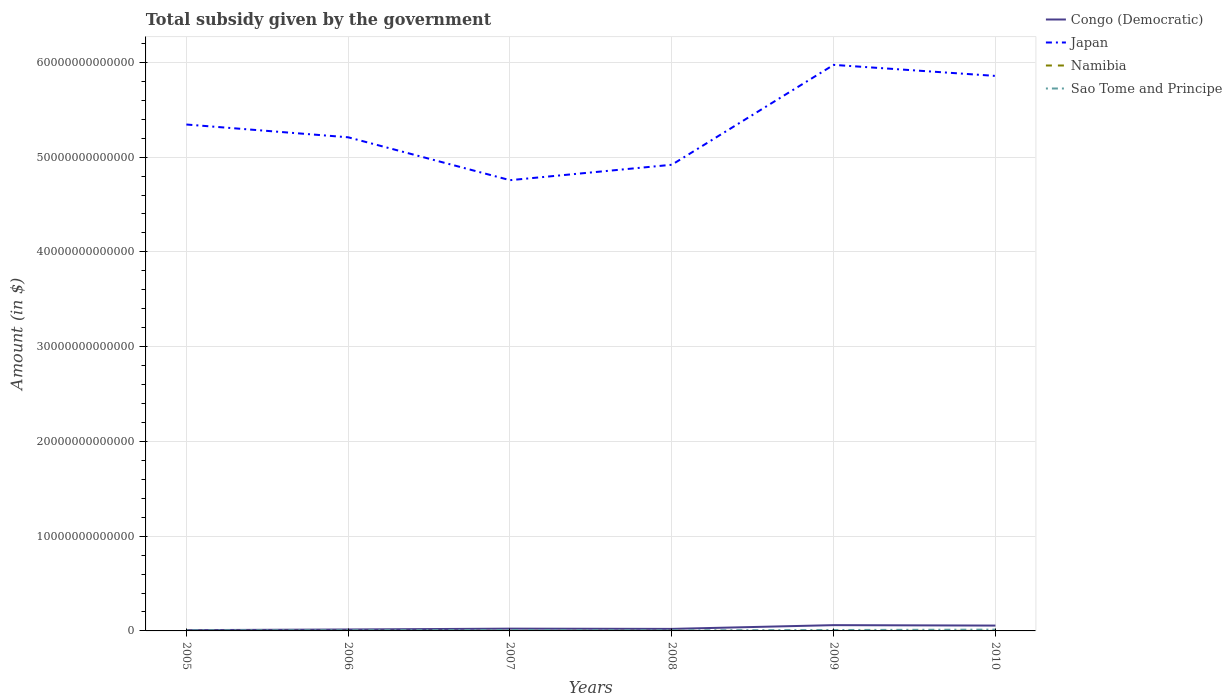Does the line corresponding to Japan intersect with the line corresponding to Sao Tome and Principe?
Keep it short and to the point. No. Is the number of lines equal to the number of legend labels?
Provide a short and direct response. Yes. Across all years, what is the maximum total revenue collected by the government in Congo (Democratic)?
Give a very brief answer. 8.19e+1. What is the total total revenue collected by the government in Sao Tome and Principe in the graph?
Offer a terse response. -3.54e+1. What is the difference between the highest and the second highest total revenue collected by the government in Congo (Democratic)?
Provide a succinct answer. 5.28e+11. Is the total revenue collected by the government in Congo (Democratic) strictly greater than the total revenue collected by the government in Japan over the years?
Provide a succinct answer. Yes. How many years are there in the graph?
Offer a very short reply. 6. What is the difference between two consecutive major ticks on the Y-axis?
Your response must be concise. 1.00e+13. Are the values on the major ticks of Y-axis written in scientific E-notation?
Your response must be concise. No. Does the graph contain any zero values?
Provide a succinct answer. No. How are the legend labels stacked?
Give a very brief answer. Vertical. What is the title of the graph?
Make the answer very short. Total subsidy given by the government. Does "Cambodia" appear as one of the legend labels in the graph?
Give a very brief answer. No. What is the label or title of the Y-axis?
Offer a very short reply. Amount (in $). What is the Amount (in $) in Congo (Democratic) in 2005?
Ensure brevity in your answer.  8.19e+1. What is the Amount (in $) in Japan in 2005?
Give a very brief answer. 5.34e+13. What is the Amount (in $) in Namibia in 2005?
Ensure brevity in your answer.  1.23e+09. What is the Amount (in $) of Sao Tome and Principe in 2005?
Provide a short and direct response. 5.85e+1. What is the Amount (in $) in Congo (Democratic) in 2006?
Your answer should be compact. 1.52e+11. What is the Amount (in $) of Japan in 2006?
Provide a short and direct response. 5.21e+13. What is the Amount (in $) in Namibia in 2006?
Your response must be concise. 1.30e+09. What is the Amount (in $) in Sao Tome and Principe in 2006?
Your response must be concise. 7.33e+1. What is the Amount (in $) in Congo (Democratic) in 2007?
Your response must be concise. 2.41e+11. What is the Amount (in $) in Japan in 2007?
Provide a succinct answer. 4.76e+13. What is the Amount (in $) in Namibia in 2007?
Provide a short and direct response. 1.99e+09. What is the Amount (in $) of Sao Tome and Principe in 2007?
Make the answer very short. 9.39e+1. What is the Amount (in $) of Congo (Democratic) in 2008?
Make the answer very short. 2.14e+11. What is the Amount (in $) of Japan in 2008?
Keep it short and to the point. 4.92e+13. What is the Amount (in $) in Namibia in 2008?
Your answer should be compact. 5.21e+09. What is the Amount (in $) in Sao Tome and Principe in 2008?
Your answer should be compact. 6.06e+1. What is the Amount (in $) of Congo (Democratic) in 2009?
Offer a terse response. 6.10e+11. What is the Amount (in $) in Japan in 2009?
Your answer should be compact. 5.97e+13. What is the Amount (in $) in Namibia in 2009?
Your answer should be compact. 5.81e+09. What is the Amount (in $) of Sao Tome and Principe in 2009?
Ensure brevity in your answer.  9.66e+1. What is the Amount (in $) in Congo (Democratic) in 2010?
Keep it short and to the point. 5.64e+11. What is the Amount (in $) in Japan in 2010?
Offer a very short reply. 5.86e+13. What is the Amount (in $) in Namibia in 2010?
Your answer should be compact. 7.49e+09. What is the Amount (in $) in Sao Tome and Principe in 2010?
Keep it short and to the point. 1.37e+11. Across all years, what is the maximum Amount (in $) in Congo (Democratic)?
Make the answer very short. 6.10e+11. Across all years, what is the maximum Amount (in $) in Japan?
Provide a short and direct response. 5.97e+13. Across all years, what is the maximum Amount (in $) of Namibia?
Make the answer very short. 7.49e+09. Across all years, what is the maximum Amount (in $) of Sao Tome and Principe?
Provide a short and direct response. 1.37e+11. Across all years, what is the minimum Amount (in $) of Congo (Democratic)?
Ensure brevity in your answer.  8.19e+1. Across all years, what is the minimum Amount (in $) in Japan?
Your answer should be very brief. 4.76e+13. Across all years, what is the minimum Amount (in $) in Namibia?
Give a very brief answer. 1.23e+09. Across all years, what is the minimum Amount (in $) in Sao Tome and Principe?
Make the answer very short. 5.85e+1. What is the total Amount (in $) in Congo (Democratic) in the graph?
Provide a short and direct response. 1.86e+12. What is the total Amount (in $) in Japan in the graph?
Make the answer very short. 3.21e+14. What is the total Amount (in $) in Namibia in the graph?
Ensure brevity in your answer.  2.30e+1. What is the total Amount (in $) in Sao Tome and Principe in the graph?
Keep it short and to the point. 5.20e+11. What is the difference between the Amount (in $) of Congo (Democratic) in 2005 and that in 2006?
Your answer should be compact. -6.97e+1. What is the difference between the Amount (in $) of Japan in 2005 and that in 2006?
Your response must be concise. 1.35e+12. What is the difference between the Amount (in $) in Namibia in 2005 and that in 2006?
Your answer should be very brief. -7.44e+07. What is the difference between the Amount (in $) of Sao Tome and Principe in 2005 and that in 2006?
Keep it short and to the point. -1.48e+1. What is the difference between the Amount (in $) of Congo (Democratic) in 2005 and that in 2007?
Provide a short and direct response. -1.59e+11. What is the difference between the Amount (in $) in Japan in 2005 and that in 2007?
Provide a succinct answer. 5.87e+12. What is the difference between the Amount (in $) of Namibia in 2005 and that in 2007?
Your answer should be compact. -7.63e+08. What is the difference between the Amount (in $) in Sao Tome and Principe in 2005 and that in 2007?
Offer a very short reply. -3.54e+1. What is the difference between the Amount (in $) in Congo (Democratic) in 2005 and that in 2008?
Make the answer very short. -1.32e+11. What is the difference between the Amount (in $) in Japan in 2005 and that in 2008?
Provide a short and direct response. 4.25e+12. What is the difference between the Amount (in $) of Namibia in 2005 and that in 2008?
Your answer should be compact. -3.98e+09. What is the difference between the Amount (in $) in Sao Tome and Principe in 2005 and that in 2008?
Your response must be concise. -2.04e+09. What is the difference between the Amount (in $) in Congo (Democratic) in 2005 and that in 2009?
Offer a terse response. -5.28e+11. What is the difference between the Amount (in $) of Japan in 2005 and that in 2009?
Make the answer very short. -6.29e+12. What is the difference between the Amount (in $) in Namibia in 2005 and that in 2009?
Your answer should be very brief. -4.58e+09. What is the difference between the Amount (in $) in Sao Tome and Principe in 2005 and that in 2009?
Your answer should be very brief. -3.81e+1. What is the difference between the Amount (in $) in Congo (Democratic) in 2005 and that in 2010?
Your answer should be very brief. -4.82e+11. What is the difference between the Amount (in $) of Japan in 2005 and that in 2010?
Offer a very short reply. -5.13e+12. What is the difference between the Amount (in $) of Namibia in 2005 and that in 2010?
Offer a very short reply. -6.26e+09. What is the difference between the Amount (in $) in Sao Tome and Principe in 2005 and that in 2010?
Give a very brief answer. -7.83e+1. What is the difference between the Amount (in $) in Congo (Democratic) in 2006 and that in 2007?
Provide a short and direct response. -8.91e+1. What is the difference between the Amount (in $) of Japan in 2006 and that in 2007?
Make the answer very short. 4.53e+12. What is the difference between the Amount (in $) of Namibia in 2006 and that in 2007?
Your response must be concise. -6.88e+08. What is the difference between the Amount (in $) in Sao Tome and Principe in 2006 and that in 2007?
Keep it short and to the point. -2.06e+1. What is the difference between the Amount (in $) in Congo (Democratic) in 2006 and that in 2008?
Your answer should be very brief. -6.25e+1. What is the difference between the Amount (in $) of Japan in 2006 and that in 2008?
Your answer should be very brief. 2.90e+12. What is the difference between the Amount (in $) of Namibia in 2006 and that in 2008?
Your response must be concise. -3.91e+09. What is the difference between the Amount (in $) in Sao Tome and Principe in 2006 and that in 2008?
Keep it short and to the point. 1.28e+1. What is the difference between the Amount (in $) of Congo (Democratic) in 2006 and that in 2009?
Provide a short and direct response. -4.58e+11. What is the difference between the Amount (in $) of Japan in 2006 and that in 2009?
Offer a terse response. -7.64e+12. What is the difference between the Amount (in $) of Namibia in 2006 and that in 2009?
Offer a terse response. -4.51e+09. What is the difference between the Amount (in $) of Sao Tome and Principe in 2006 and that in 2009?
Offer a terse response. -2.33e+1. What is the difference between the Amount (in $) of Congo (Democratic) in 2006 and that in 2010?
Your answer should be very brief. -4.12e+11. What is the difference between the Amount (in $) in Japan in 2006 and that in 2010?
Offer a terse response. -6.48e+12. What is the difference between the Amount (in $) in Namibia in 2006 and that in 2010?
Provide a succinct answer. -6.18e+09. What is the difference between the Amount (in $) of Sao Tome and Principe in 2006 and that in 2010?
Your answer should be very brief. -6.35e+1. What is the difference between the Amount (in $) in Congo (Democratic) in 2007 and that in 2008?
Your answer should be very brief. 2.66e+1. What is the difference between the Amount (in $) of Japan in 2007 and that in 2008?
Make the answer very short. -1.63e+12. What is the difference between the Amount (in $) of Namibia in 2007 and that in 2008?
Offer a terse response. -3.22e+09. What is the difference between the Amount (in $) of Sao Tome and Principe in 2007 and that in 2008?
Your answer should be very brief. 3.34e+1. What is the difference between the Amount (in $) in Congo (Democratic) in 2007 and that in 2009?
Your response must be concise. -3.69e+11. What is the difference between the Amount (in $) in Japan in 2007 and that in 2009?
Make the answer very short. -1.22e+13. What is the difference between the Amount (in $) of Namibia in 2007 and that in 2009?
Ensure brevity in your answer.  -3.82e+09. What is the difference between the Amount (in $) in Sao Tome and Principe in 2007 and that in 2009?
Keep it short and to the point. -2.74e+09. What is the difference between the Amount (in $) of Congo (Democratic) in 2007 and that in 2010?
Provide a short and direct response. -3.23e+11. What is the difference between the Amount (in $) in Japan in 2007 and that in 2010?
Provide a succinct answer. -1.10e+13. What is the difference between the Amount (in $) in Namibia in 2007 and that in 2010?
Make the answer very short. -5.49e+09. What is the difference between the Amount (in $) of Sao Tome and Principe in 2007 and that in 2010?
Offer a terse response. -4.29e+1. What is the difference between the Amount (in $) in Congo (Democratic) in 2008 and that in 2009?
Make the answer very short. -3.96e+11. What is the difference between the Amount (in $) of Japan in 2008 and that in 2009?
Provide a short and direct response. -1.05e+13. What is the difference between the Amount (in $) of Namibia in 2008 and that in 2009?
Your answer should be very brief. -6.00e+08. What is the difference between the Amount (in $) of Sao Tome and Principe in 2008 and that in 2009?
Your answer should be compact. -3.61e+1. What is the difference between the Amount (in $) of Congo (Democratic) in 2008 and that in 2010?
Make the answer very short. -3.50e+11. What is the difference between the Amount (in $) in Japan in 2008 and that in 2010?
Provide a succinct answer. -9.38e+12. What is the difference between the Amount (in $) of Namibia in 2008 and that in 2010?
Keep it short and to the point. -2.28e+09. What is the difference between the Amount (in $) of Sao Tome and Principe in 2008 and that in 2010?
Your answer should be compact. -7.63e+1. What is the difference between the Amount (in $) in Congo (Democratic) in 2009 and that in 2010?
Make the answer very short. 4.60e+1. What is the difference between the Amount (in $) in Japan in 2009 and that in 2010?
Provide a short and direct response. 1.16e+12. What is the difference between the Amount (in $) of Namibia in 2009 and that in 2010?
Provide a succinct answer. -1.68e+09. What is the difference between the Amount (in $) in Sao Tome and Principe in 2009 and that in 2010?
Your answer should be compact. -4.02e+1. What is the difference between the Amount (in $) in Congo (Democratic) in 2005 and the Amount (in $) in Japan in 2006?
Your response must be concise. -5.20e+13. What is the difference between the Amount (in $) of Congo (Democratic) in 2005 and the Amount (in $) of Namibia in 2006?
Your response must be concise. 8.06e+1. What is the difference between the Amount (in $) of Congo (Democratic) in 2005 and the Amount (in $) of Sao Tome and Principe in 2006?
Your answer should be compact. 8.57e+09. What is the difference between the Amount (in $) in Japan in 2005 and the Amount (in $) in Namibia in 2006?
Your answer should be very brief. 5.34e+13. What is the difference between the Amount (in $) of Japan in 2005 and the Amount (in $) of Sao Tome and Principe in 2006?
Keep it short and to the point. 5.34e+13. What is the difference between the Amount (in $) of Namibia in 2005 and the Amount (in $) of Sao Tome and Principe in 2006?
Make the answer very short. -7.21e+1. What is the difference between the Amount (in $) in Congo (Democratic) in 2005 and the Amount (in $) in Japan in 2007?
Offer a very short reply. -4.75e+13. What is the difference between the Amount (in $) in Congo (Democratic) in 2005 and the Amount (in $) in Namibia in 2007?
Ensure brevity in your answer.  7.99e+1. What is the difference between the Amount (in $) in Congo (Democratic) in 2005 and the Amount (in $) in Sao Tome and Principe in 2007?
Your response must be concise. -1.20e+1. What is the difference between the Amount (in $) in Japan in 2005 and the Amount (in $) in Namibia in 2007?
Give a very brief answer. 5.34e+13. What is the difference between the Amount (in $) in Japan in 2005 and the Amount (in $) in Sao Tome and Principe in 2007?
Your answer should be very brief. 5.33e+13. What is the difference between the Amount (in $) in Namibia in 2005 and the Amount (in $) in Sao Tome and Principe in 2007?
Provide a succinct answer. -9.27e+1. What is the difference between the Amount (in $) of Congo (Democratic) in 2005 and the Amount (in $) of Japan in 2008?
Your answer should be compact. -4.91e+13. What is the difference between the Amount (in $) of Congo (Democratic) in 2005 and the Amount (in $) of Namibia in 2008?
Your answer should be very brief. 7.67e+1. What is the difference between the Amount (in $) of Congo (Democratic) in 2005 and the Amount (in $) of Sao Tome and Principe in 2008?
Keep it short and to the point. 2.13e+1. What is the difference between the Amount (in $) of Japan in 2005 and the Amount (in $) of Namibia in 2008?
Your answer should be very brief. 5.34e+13. What is the difference between the Amount (in $) in Japan in 2005 and the Amount (in $) in Sao Tome and Principe in 2008?
Provide a short and direct response. 5.34e+13. What is the difference between the Amount (in $) in Namibia in 2005 and the Amount (in $) in Sao Tome and Principe in 2008?
Give a very brief answer. -5.93e+1. What is the difference between the Amount (in $) in Congo (Democratic) in 2005 and the Amount (in $) in Japan in 2009?
Offer a terse response. -5.97e+13. What is the difference between the Amount (in $) in Congo (Democratic) in 2005 and the Amount (in $) in Namibia in 2009?
Your response must be concise. 7.61e+1. What is the difference between the Amount (in $) in Congo (Democratic) in 2005 and the Amount (in $) in Sao Tome and Principe in 2009?
Offer a very short reply. -1.48e+1. What is the difference between the Amount (in $) of Japan in 2005 and the Amount (in $) of Namibia in 2009?
Keep it short and to the point. 5.34e+13. What is the difference between the Amount (in $) in Japan in 2005 and the Amount (in $) in Sao Tome and Principe in 2009?
Give a very brief answer. 5.33e+13. What is the difference between the Amount (in $) of Namibia in 2005 and the Amount (in $) of Sao Tome and Principe in 2009?
Provide a short and direct response. -9.54e+1. What is the difference between the Amount (in $) in Congo (Democratic) in 2005 and the Amount (in $) in Japan in 2010?
Your answer should be very brief. -5.85e+13. What is the difference between the Amount (in $) in Congo (Democratic) in 2005 and the Amount (in $) in Namibia in 2010?
Your response must be concise. 7.44e+1. What is the difference between the Amount (in $) in Congo (Democratic) in 2005 and the Amount (in $) in Sao Tome and Principe in 2010?
Give a very brief answer. -5.50e+1. What is the difference between the Amount (in $) of Japan in 2005 and the Amount (in $) of Namibia in 2010?
Offer a terse response. 5.34e+13. What is the difference between the Amount (in $) of Japan in 2005 and the Amount (in $) of Sao Tome and Principe in 2010?
Your response must be concise. 5.33e+13. What is the difference between the Amount (in $) in Namibia in 2005 and the Amount (in $) in Sao Tome and Principe in 2010?
Provide a short and direct response. -1.36e+11. What is the difference between the Amount (in $) in Congo (Democratic) in 2006 and the Amount (in $) in Japan in 2007?
Offer a very short reply. -4.74e+13. What is the difference between the Amount (in $) of Congo (Democratic) in 2006 and the Amount (in $) of Namibia in 2007?
Give a very brief answer. 1.50e+11. What is the difference between the Amount (in $) in Congo (Democratic) in 2006 and the Amount (in $) in Sao Tome and Principe in 2007?
Offer a terse response. 5.77e+1. What is the difference between the Amount (in $) of Japan in 2006 and the Amount (in $) of Namibia in 2007?
Make the answer very short. 5.21e+13. What is the difference between the Amount (in $) of Japan in 2006 and the Amount (in $) of Sao Tome and Principe in 2007?
Your answer should be very brief. 5.20e+13. What is the difference between the Amount (in $) in Namibia in 2006 and the Amount (in $) in Sao Tome and Principe in 2007?
Provide a short and direct response. -9.26e+1. What is the difference between the Amount (in $) of Congo (Democratic) in 2006 and the Amount (in $) of Japan in 2008?
Provide a succinct answer. -4.90e+13. What is the difference between the Amount (in $) in Congo (Democratic) in 2006 and the Amount (in $) in Namibia in 2008?
Your answer should be very brief. 1.46e+11. What is the difference between the Amount (in $) of Congo (Democratic) in 2006 and the Amount (in $) of Sao Tome and Principe in 2008?
Offer a terse response. 9.10e+1. What is the difference between the Amount (in $) in Japan in 2006 and the Amount (in $) in Namibia in 2008?
Your answer should be compact. 5.21e+13. What is the difference between the Amount (in $) of Japan in 2006 and the Amount (in $) of Sao Tome and Principe in 2008?
Ensure brevity in your answer.  5.20e+13. What is the difference between the Amount (in $) of Namibia in 2006 and the Amount (in $) of Sao Tome and Principe in 2008?
Ensure brevity in your answer.  -5.92e+1. What is the difference between the Amount (in $) of Congo (Democratic) in 2006 and the Amount (in $) of Japan in 2009?
Your answer should be very brief. -5.96e+13. What is the difference between the Amount (in $) of Congo (Democratic) in 2006 and the Amount (in $) of Namibia in 2009?
Your answer should be very brief. 1.46e+11. What is the difference between the Amount (in $) of Congo (Democratic) in 2006 and the Amount (in $) of Sao Tome and Principe in 2009?
Ensure brevity in your answer.  5.49e+1. What is the difference between the Amount (in $) of Japan in 2006 and the Amount (in $) of Namibia in 2009?
Give a very brief answer. 5.21e+13. What is the difference between the Amount (in $) in Japan in 2006 and the Amount (in $) in Sao Tome and Principe in 2009?
Give a very brief answer. 5.20e+13. What is the difference between the Amount (in $) of Namibia in 2006 and the Amount (in $) of Sao Tome and Principe in 2009?
Make the answer very short. -9.53e+1. What is the difference between the Amount (in $) of Congo (Democratic) in 2006 and the Amount (in $) of Japan in 2010?
Give a very brief answer. -5.84e+13. What is the difference between the Amount (in $) of Congo (Democratic) in 2006 and the Amount (in $) of Namibia in 2010?
Keep it short and to the point. 1.44e+11. What is the difference between the Amount (in $) in Congo (Democratic) in 2006 and the Amount (in $) in Sao Tome and Principe in 2010?
Your answer should be compact. 1.47e+1. What is the difference between the Amount (in $) in Japan in 2006 and the Amount (in $) in Namibia in 2010?
Provide a succinct answer. 5.21e+13. What is the difference between the Amount (in $) in Japan in 2006 and the Amount (in $) in Sao Tome and Principe in 2010?
Your answer should be very brief. 5.20e+13. What is the difference between the Amount (in $) in Namibia in 2006 and the Amount (in $) in Sao Tome and Principe in 2010?
Your answer should be very brief. -1.36e+11. What is the difference between the Amount (in $) in Congo (Democratic) in 2007 and the Amount (in $) in Japan in 2008?
Give a very brief answer. -4.90e+13. What is the difference between the Amount (in $) of Congo (Democratic) in 2007 and the Amount (in $) of Namibia in 2008?
Provide a succinct answer. 2.36e+11. What is the difference between the Amount (in $) of Congo (Democratic) in 2007 and the Amount (in $) of Sao Tome and Principe in 2008?
Your answer should be compact. 1.80e+11. What is the difference between the Amount (in $) of Japan in 2007 and the Amount (in $) of Namibia in 2008?
Provide a short and direct response. 4.76e+13. What is the difference between the Amount (in $) of Japan in 2007 and the Amount (in $) of Sao Tome and Principe in 2008?
Offer a terse response. 4.75e+13. What is the difference between the Amount (in $) in Namibia in 2007 and the Amount (in $) in Sao Tome and Principe in 2008?
Your answer should be very brief. -5.86e+1. What is the difference between the Amount (in $) in Congo (Democratic) in 2007 and the Amount (in $) in Japan in 2009?
Your response must be concise. -5.95e+13. What is the difference between the Amount (in $) of Congo (Democratic) in 2007 and the Amount (in $) of Namibia in 2009?
Your response must be concise. 2.35e+11. What is the difference between the Amount (in $) of Congo (Democratic) in 2007 and the Amount (in $) of Sao Tome and Principe in 2009?
Offer a terse response. 1.44e+11. What is the difference between the Amount (in $) in Japan in 2007 and the Amount (in $) in Namibia in 2009?
Your response must be concise. 4.76e+13. What is the difference between the Amount (in $) of Japan in 2007 and the Amount (in $) of Sao Tome and Principe in 2009?
Provide a short and direct response. 4.75e+13. What is the difference between the Amount (in $) in Namibia in 2007 and the Amount (in $) in Sao Tome and Principe in 2009?
Ensure brevity in your answer.  -9.47e+1. What is the difference between the Amount (in $) in Congo (Democratic) in 2007 and the Amount (in $) in Japan in 2010?
Your answer should be compact. -5.83e+13. What is the difference between the Amount (in $) in Congo (Democratic) in 2007 and the Amount (in $) in Namibia in 2010?
Your answer should be very brief. 2.33e+11. What is the difference between the Amount (in $) of Congo (Democratic) in 2007 and the Amount (in $) of Sao Tome and Principe in 2010?
Give a very brief answer. 1.04e+11. What is the difference between the Amount (in $) of Japan in 2007 and the Amount (in $) of Namibia in 2010?
Provide a succinct answer. 4.76e+13. What is the difference between the Amount (in $) of Japan in 2007 and the Amount (in $) of Sao Tome and Principe in 2010?
Offer a terse response. 4.74e+13. What is the difference between the Amount (in $) in Namibia in 2007 and the Amount (in $) in Sao Tome and Principe in 2010?
Your response must be concise. -1.35e+11. What is the difference between the Amount (in $) of Congo (Democratic) in 2008 and the Amount (in $) of Japan in 2009?
Keep it short and to the point. -5.95e+13. What is the difference between the Amount (in $) of Congo (Democratic) in 2008 and the Amount (in $) of Namibia in 2009?
Offer a terse response. 2.08e+11. What is the difference between the Amount (in $) in Congo (Democratic) in 2008 and the Amount (in $) in Sao Tome and Principe in 2009?
Your response must be concise. 1.17e+11. What is the difference between the Amount (in $) of Japan in 2008 and the Amount (in $) of Namibia in 2009?
Provide a succinct answer. 4.92e+13. What is the difference between the Amount (in $) in Japan in 2008 and the Amount (in $) in Sao Tome and Principe in 2009?
Your answer should be very brief. 4.91e+13. What is the difference between the Amount (in $) in Namibia in 2008 and the Amount (in $) in Sao Tome and Principe in 2009?
Keep it short and to the point. -9.14e+1. What is the difference between the Amount (in $) of Congo (Democratic) in 2008 and the Amount (in $) of Japan in 2010?
Make the answer very short. -5.84e+13. What is the difference between the Amount (in $) of Congo (Democratic) in 2008 and the Amount (in $) of Namibia in 2010?
Give a very brief answer. 2.07e+11. What is the difference between the Amount (in $) in Congo (Democratic) in 2008 and the Amount (in $) in Sao Tome and Principe in 2010?
Provide a short and direct response. 7.73e+1. What is the difference between the Amount (in $) in Japan in 2008 and the Amount (in $) in Namibia in 2010?
Your answer should be compact. 4.92e+13. What is the difference between the Amount (in $) of Japan in 2008 and the Amount (in $) of Sao Tome and Principe in 2010?
Provide a short and direct response. 4.91e+13. What is the difference between the Amount (in $) in Namibia in 2008 and the Amount (in $) in Sao Tome and Principe in 2010?
Provide a succinct answer. -1.32e+11. What is the difference between the Amount (in $) in Congo (Democratic) in 2009 and the Amount (in $) in Japan in 2010?
Offer a very short reply. -5.80e+13. What is the difference between the Amount (in $) in Congo (Democratic) in 2009 and the Amount (in $) in Namibia in 2010?
Your answer should be very brief. 6.02e+11. What is the difference between the Amount (in $) of Congo (Democratic) in 2009 and the Amount (in $) of Sao Tome and Principe in 2010?
Your answer should be compact. 4.73e+11. What is the difference between the Amount (in $) in Japan in 2009 and the Amount (in $) in Namibia in 2010?
Make the answer very short. 5.97e+13. What is the difference between the Amount (in $) in Japan in 2009 and the Amount (in $) in Sao Tome and Principe in 2010?
Your response must be concise. 5.96e+13. What is the difference between the Amount (in $) in Namibia in 2009 and the Amount (in $) in Sao Tome and Principe in 2010?
Your answer should be compact. -1.31e+11. What is the average Amount (in $) in Congo (Democratic) per year?
Provide a short and direct response. 3.10e+11. What is the average Amount (in $) of Japan per year?
Give a very brief answer. 5.34e+13. What is the average Amount (in $) of Namibia per year?
Make the answer very short. 3.84e+09. What is the average Amount (in $) in Sao Tome and Principe per year?
Make the answer very short. 8.66e+1. In the year 2005, what is the difference between the Amount (in $) in Congo (Democratic) and Amount (in $) in Japan?
Keep it short and to the point. -5.34e+13. In the year 2005, what is the difference between the Amount (in $) of Congo (Democratic) and Amount (in $) of Namibia?
Your answer should be very brief. 8.07e+1. In the year 2005, what is the difference between the Amount (in $) in Congo (Democratic) and Amount (in $) in Sao Tome and Principe?
Provide a succinct answer. 2.34e+1. In the year 2005, what is the difference between the Amount (in $) of Japan and Amount (in $) of Namibia?
Give a very brief answer. 5.34e+13. In the year 2005, what is the difference between the Amount (in $) of Japan and Amount (in $) of Sao Tome and Principe?
Provide a short and direct response. 5.34e+13. In the year 2005, what is the difference between the Amount (in $) of Namibia and Amount (in $) of Sao Tome and Principe?
Your response must be concise. -5.73e+1. In the year 2006, what is the difference between the Amount (in $) of Congo (Democratic) and Amount (in $) of Japan?
Make the answer very short. -5.19e+13. In the year 2006, what is the difference between the Amount (in $) of Congo (Democratic) and Amount (in $) of Namibia?
Ensure brevity in your answer.  1.50e+11. In the year 2006, what is the difference between the Amount (in $) of Congo (Democratic) and Amount (in $) of Sao Tome and Principe?
Provide a short and direct response. 7.83e+1. In the year 2006, what is the difference between the Amount (in $) in Japan and Amount (in $) in Namibia?
Give a very brief answer. 5.21e+13. In the year 2006, what is the difference between the Amount (in $) in Japan and Amount (in $) in Sao Tome and Principe?
Ensure brevity in your answer.  5.20e+13. In the year 2006, what is the difference between the Amount (in $) of Namibia and Amount (in $) of Sao Tome and Principe?
Your answer should be compact. -7.20e+1. In the year 2007, what is the difference between the Amount (in $) in Congo (Democratic) and Amount (in $) in Japan?
Give a very brief answer. -4.73e+13. In the year 2007, what is the difference between the Amount (in $) of Congo (Democratic) and Amount (in $) of Namibia?
Provide a succinct answer. 2.39e+11. In the year 2007, what is the difference between the Amount (in $) of Congo (Democratic) and Amount (in $) of Sao Tome and Principe?
Your answer should be compact. 1.47e+11. In the year 2007, what is the difference between the Amount (in $) in Japan and Amount (in $) in Namibia?
Offer a very short reply. 4.76e+13. In the year 2007, what is the difference between the Amount (in $) of Japan and Amount (in $) of Sao Tome and Principe?
Provide a succinct answer. 4.75e+13. In the year 2007, what is the difference between the Amount (in $) in Namibia and Amount (in $) in Sao Tome and Principe?
Your answer should be compact. -9.19e+1. In the year 2008, what is the difference between the Amount (in $) in Congo (Democratic) and Amount (in $) in Japan?
Offer a very short reply. -4.90e+13. In the year 2008, what is the difference between the Amount (in $) of Congo (Democratic) and Amount (in $) of Namibia?
Provide a succinct answer. 2.09e+11. In the year 2008, what is the difference between the Amount (in $) of Congo (Democratic) and Amount (in $) of Sao Tome and Principe?
Give a very brief answer. 1.54e+11. In the year 2008, what is the difference between the Amount (in $) in Japan and Amount (in $) in Namibia?
Offer a very short reply. 4.92e+13. In the year 2008, what is the difference between the Amount (in $) of Japan and Amount (in $) of Sao Tome and Principe?
Provide a succinct answer. 4.91e+13. In the year 2008, what is the difference between the Amount (in $) in Namibia and Amount (in $) in Sao Tome and Principe?
Offer a terse response. -5.53e+1. In the year 2009, what is the difference between the Amount (in $) of Congo (Democratic) and Amount (in $) of Japan?
Provide a succinct answer. -5.91e+13. In the year 2009, what is the difference between the Amount (in $) of Congo (Democratic) and Amount (in $) of Namibia?
Make the answer very short. 6.04e+11. In the year 2009, what is the difference between the Amount (in $) of Congo (Democratic) and Amount (in $) of Sao Tome and Principe?
Your answer should be compact. 5.13e+11. In the year 2009, what is the difference between the Amount (in $) of Japan and Amount (in $) of Namibia?
Keep it short and to the point. 5.97e+13. In the year 2009, what is the difference between the Amount (in $) of Japan and Amount (in $) of Sao Tome and Principe?
Your answer should be compact. 5.96e+13. In the year 2009, what is the difference between the Amount (in $) in Namibia and Amount (in $) in Sao Tome and Principe?
Ensure brevity in your answer.  -9.08e+1. In the year 2010, what is the difference between the Amount (in $) in Congo (Democratic) and Amount (in $) in Japan?
Keep it short and to the point. -5.80e+13. In the year 2010, what is the difference between the Amount (in $) of Congo (Democratic) and Amount (in $) of Namibia?
Ensure brevity in your answer.  5.56e+11. In the year 2010, what is the difference between the Amount (in $) in Congo (Democratic) and Amount (in $) in Sao Tome and Principe?
Provide a succinct answer. 4.27e+11. In the year 2010, what is the difference between the Amount (in $) in Japan and Amount (in $) in Namibia?
Give a very brief answer. 5.86e+13. In the year 2010, what is the difference between the Amount (in $) in Japan and Amount (in $) in Sao Tome and Principe?
Provide a succinct answer. 5.84e+13. In the year 2010, what is the difference between the Amount (in $) of Namibia and Amount (in $) of Sao Tome and Principe?
Your response must be concise. -1.29e+11. What is the ratio of the Amount (in $) of Congo (Democratic) in 2005 to that in 2006?
Ensure brevity in your answer.  0.54. What is the ratio of the Amount (in $) in Japan in 2005 to that in 2006?
Make the answer very short. 1.03. What is the ratio of the Amount (in $) in Namibia in 2005 to that in 2006?
Provide a short and direct response. 0.94. What is the ratio of the Amount (in $) in Sao Tome and Principe in 2005 to that in 2006?
Give a very brief answer. 0.8. What is the ratio of the Amount (in $) in Congo (Democratic) in 2005 to that in 2007?
Keep it short and to the point. 0.34. What is the ratio of the Amount (in $) of Japan in 2005 to that in 2007?
Ensure brevity in your answer.  1.12. What is the ratio of the Amount (in $) of Namibia in 2005 to that in 2007?
Offer a very short reply. 0.62. What is the ratio of the Amount (in $) in Sao Tome and Principe in 2005 to that in 2007?
Give a very brief answer. 0.62. What is the ratio of the Amount (in $) of Congo (Democratic) in 2005 to that in 2008?
Offer a very short reply. 0.38. What is the ratio of the Amount (in $) in Japan in 2005 to that in 2008?
Give a very brief answer. 1.09. What is the ratio of the Amount (in $) in Namibia in 2005 to that in 2008?
Your answer should be very brief. 0.24. What is the ratio of the Amount (in $) in Sao Tome and Principe in 2005 to that in 2008?
Offer a terse response. 0.97. What is the ratio of the Amount (in $) in Congo (Democratic) in 2005 to that in 2009?
Your answer should be very brief. 0.13. What is the ratio of the Amount (in $) in Japan in 2005 to that in 2009?
Give a very brief answer. 0.89. What is the ratio of the Amount (in $) in Namibia in 2005 to that in 2009?
Make the answer very short. 0.21. What is the ratio of the Amount (in $) in Sao Tome and Principe in 2005 to that in 2009?
Your response must be concise. 0.61. What is the ratio of the Amount (in $) of Congo (Democratic) in 2005 to that in 2010?
Offer a very short reply. 0.15. What is the ratio of the Amount (in $) in Japan in 2005 to that in 2010?
Offer a very short reply. 0.91. What is the ratio of the Amount (in $) in Namibia in 2005 to that in 2010?
Give a very brief answer. 0.16. What is the ratio of the Amount (in $) in Sao Tome and Principe in 2005 to that in 2010?
Ensure brevity in your answer.  0.43. What is the ratio of the Amount (in $) in Congo (Democratic) in 2006 to that in 2007?
Offer a terse response. 0.63. What is the ratio of the Amount (in $) in Japan in 2006 to that in 2007?
Ensure brevity in your answer.  1.1. What is the ratio of the Amount (in $) in Namibia in 2006 to that in 2007?
Make the answer very short. 0.65. What is the ratio of the Amount (in $) in Sao Tome and Principe in 2006 to that in 2007?
Give a very brief answer. 0.78. What is the ratio of the Amount (in $) of Congo (Democratic) in 2006 to that in 2008?
Give a very brief answer. 0.71. What is the ratio of the Amount (in $) in Japan in 2006 to that in 2008?
Provide a short and direct response. 1.06. What is the ratio of the Amount (in $) in Namibia in 2006 to that in 2008?
Offer a terse response. 0.25. What is the ratio of the Amount (in $) of Sao Tome and Principe in 2006 to that in 2008?
Provide a succinct answer. 1.21. What is the ratio of the Amount (in $) of Congo (Democratic) in 2006 to that in 2009?
Provide a succinct answer. 0.25. What is the ratio of the Amount (in $) of Japan in 2006 to that in 2009?
Provide a short and direct response. 0.87. What is the ratio of the Amount (in $) in Namibia in 2006 to that in 2009?
Keep it short and to the point. 0.22. What is the ratio of the Amount (in $) of Sao Tome and Principe in 2006 to that in 2009?
Provide a succinct answer. 0.76. What is the ratio of the Amount (in $) of Congo (Democratic) in 2006 to that in 2010?
Offer a very short reply. 0.27. What is the ratio of the Amount (in $) in Japan in 2006 to that in 2010?
Your answer should be compact. 0.89. What is the ratio of the Amount (in $) in Namibia in 2006 to that in 2010?
Your answer should be compact. 0.17. What is the ratio of the Amount (in $) in Sao Tome and Principe in 2006 to that in 2010?
Keep it short and to the point. 0.54. What is the ratio of the Amount (in $) in Congo (Democratic) in 2007 to that in 2008?
Offer a terse response. 1.12. What is the ratio of the Amount (in $) in Japan in 2007 to that in 2008?
Your answer should be very brief. 0.97. What is the ratio of the Amount (in $) in Namibia in 2007 to that in 2008?
Your answer should be compact. 0.38. What is the ratio of the Amount (in $) of Sao Tome and Principe in 2007 to that in 2008?
Offer a terse response. 1.55. What is the ratio of the Amount (in $) of Congo (Democratic) in 2007 to that in 2009?
Your response must be concise. 0.39. What is the ratio of the Amount (in $) of Japan in 2007 to that in 2009?
Make the answer very short. 0.8. What is the ratio of the Amount (in $) in Namibia in 2007 to that in 2009?
Make the answer very short. 0.34. What is the ratio of the Amount (in $) in Sao Tome and Principe in 2007 to that in 2009?
Provide a short and direct response. 0.97. What is the ratio of the Amount (in $) in Congo (Democratic) in 2007 to that in 2010?
Offer a terse response. 0.43. What is the ratio of the Amount (in $) in Japan in 2007 to that in 2010?
Make the answer very short. 0.81. What is the ratio of the Amount (in $) in Namibia in 2007 to that in 2010?
Ensure brevity in your answer.  0.27. What is the ratio of the Amount (in $) in Sao Tome and Principe in 2007 to that in 2010?
Your response must be concise. 0.69. What is the ratio of the Amount (in $) of Congo (Democratic) in 2008 to that in 2009?
Ensure brevity in your answer.  0.35. What is the ratio of the Amount (in $) in Japan in 2008 to that in 2009?
Your answer should be very brief. 0.82. What is the ratio of the Amount (in $) in Namibia in 2008 to that in 2009?
Your answer should be compact. 0.9. What is the ratio of the Amount (in $) in Sao Tome and Principe in 2008 to that in 2009?
Give a very brief answer. 0.63. What is the ratio of the Amount (in $) of Congo (Democratic) in 2008 to that in 2010?
Provide a succinct answer. 0.38. What is the ratio of the Amount (in $) of Japan in 2008 to that in 2010?
Provide a short and direct response. 0.84. What is the ratio of the Amount (in $) of Namibia in 2008 to that in 2010?
Provide a succinct answer. 0.7. What is the ratio of the Amount (in $) of Sao Tome and Principe in 2008 to that in 2010?
Provide a short and direct response. 0.44. What is the ratio of the Amount (in $) of Congo (Democratic) in 2009 to that in 2010?
Your answer should be very brief. 1.08. What is the ratio of the Amount (in $) of Japan in 2009 to that in 2010?
Offer a terse response. 1.02. What is the ratio of the Amount (in $) in Namibia in 2009 to that in 2010?
Provide a succinct answer. 0.78. What is the ratio of the Amount (in $) in Sao Tome and Principe in 2009 to that in 2010?
Your answer should be very brief. 0.71. What is the difference between the highest and the second highest Amount (in $) in Congo (Democratic)?
Make the answer very short. 4.60e+1. What is the difference between the highest and the second highest Amount (in $) in Japan?
Provide a short and direct response. 1.16e+12. What is the difference between the highest and the second highest Amount (in $) of Namibia?
Provide a short and direct response. 1.68e+09. What is the difference between the highest and the second highest Amount (in $) of Sao Tome and Principe?
Make the answer very short. 4.02e+1. What is the difference between the highest and the lowest Amount (in $) in Congo (Democratic)?
Offer a terse response. 5.28e+11. What is the difference between the highest and the lowest Amount (in $) of Japan?
Ensure brevity in your answer.  1.22e+13. What is the difference between the highest and the lowest Amount (in $) in Namibia?
Give a very brief answer. 6.26e+09. What is the difference between the highest and the lowest Amount (in $) in Sao Tome and Principe?
Offer a terse response. 7.83e+1. 